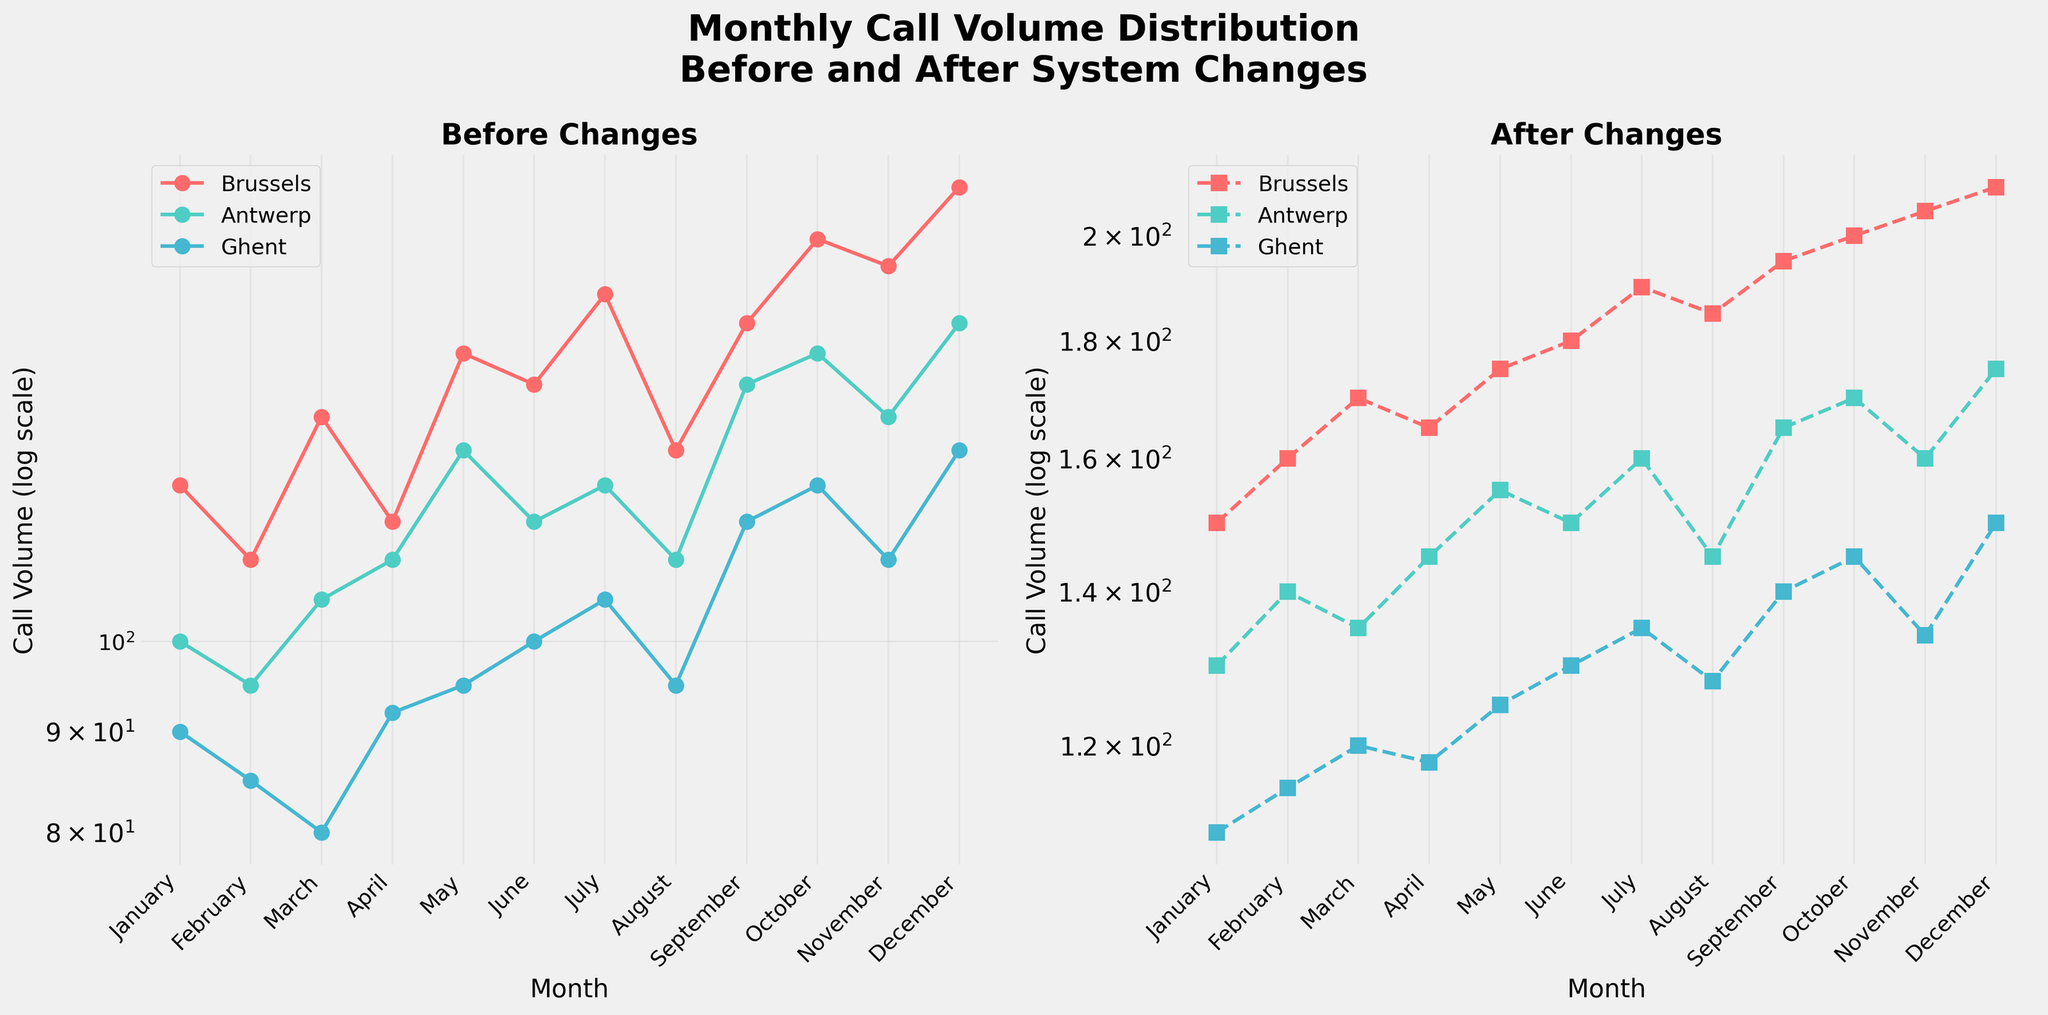What's the trend of call volumes in Brussels after the recent system changes? Looking at the subplot for "After Changes," we see that the call volume in Brussels increases steadily from January to December.
Answer: Increasing Which month had the highest call volume in Antwerp before the system changes? In the subplot labeled "Before Changes," the highest point for Antwerp in the solid line appears in December.
Answer: December What is the call volume difference in Ghent before and after the system changes in February? Referring to the data points for February in both subplots for Ghent, we see call volumes before and after changes are 85 and 115, respectively. Therefore, the difference is 115 - 85.
Answer: 30 Was there a month where the call volume in Brussels was the same before and after the system changes? No month in Brussels shows the same call volume before and after the changes, as seen by the separate lines in both subplots.
Answer: No Did Antwerp experience a higher call volume in July or September after the system changes? In the subplot for "After Changes," the data point for Antwerp in September is higher than in July.
Answer: September How does the call volume in Ghent compare between April and October before the system changes? Referring to the "Before Changes" subplot for Ghent, the call volume in April is slightly less than in October.
Answer: April < October What's the average call volume in Brussels for the months of May through July before the system changes? Summing the call volumes in Brussels for May, June, and July before the changes gives 140 + 135 + 150 = 425. Dividing by 3, the average is 425/3.
Answer: 141.67 Which zone had a steeper increase in call volume after the system changes from January to December? Observing the "After Changes" subplot, Brussels has the steepest increase in call volume among the three zones.
Answer: Brussels What is the call volume in Ghent after the system changes in October? In the "After Changes" subplot, the data point for Ghent in October is 145.
Answer: 145 Are the call volumes in Antwerp generally higher before or after the system changes? Comparing both subplots, the call volumes in Antwerp are consistently higher after the system changes.
Answer: After 